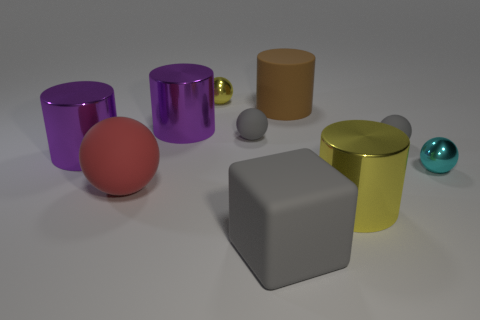Subtract 1 spheres. How many spheres are left? 4 Subtract all yellow spheres. How many spheres are left? 4 Subtract all large red balls. How many balls are left? 4 Subtract all cyan balls. Subtract all blue cubes. How many balls are left? 4 Subtract all cubes. How many objects are left? 9 Subtract all brown cylinders. Subtract all metal balls. How many objects are left? 7 Add 4 yellow spheres. How many yellow spheres are left? 5 Add 4 tiny matte objects. How many tiny matte objects exist? 6 Subtract 0 cyan cylinders. How many objects are left? 10 